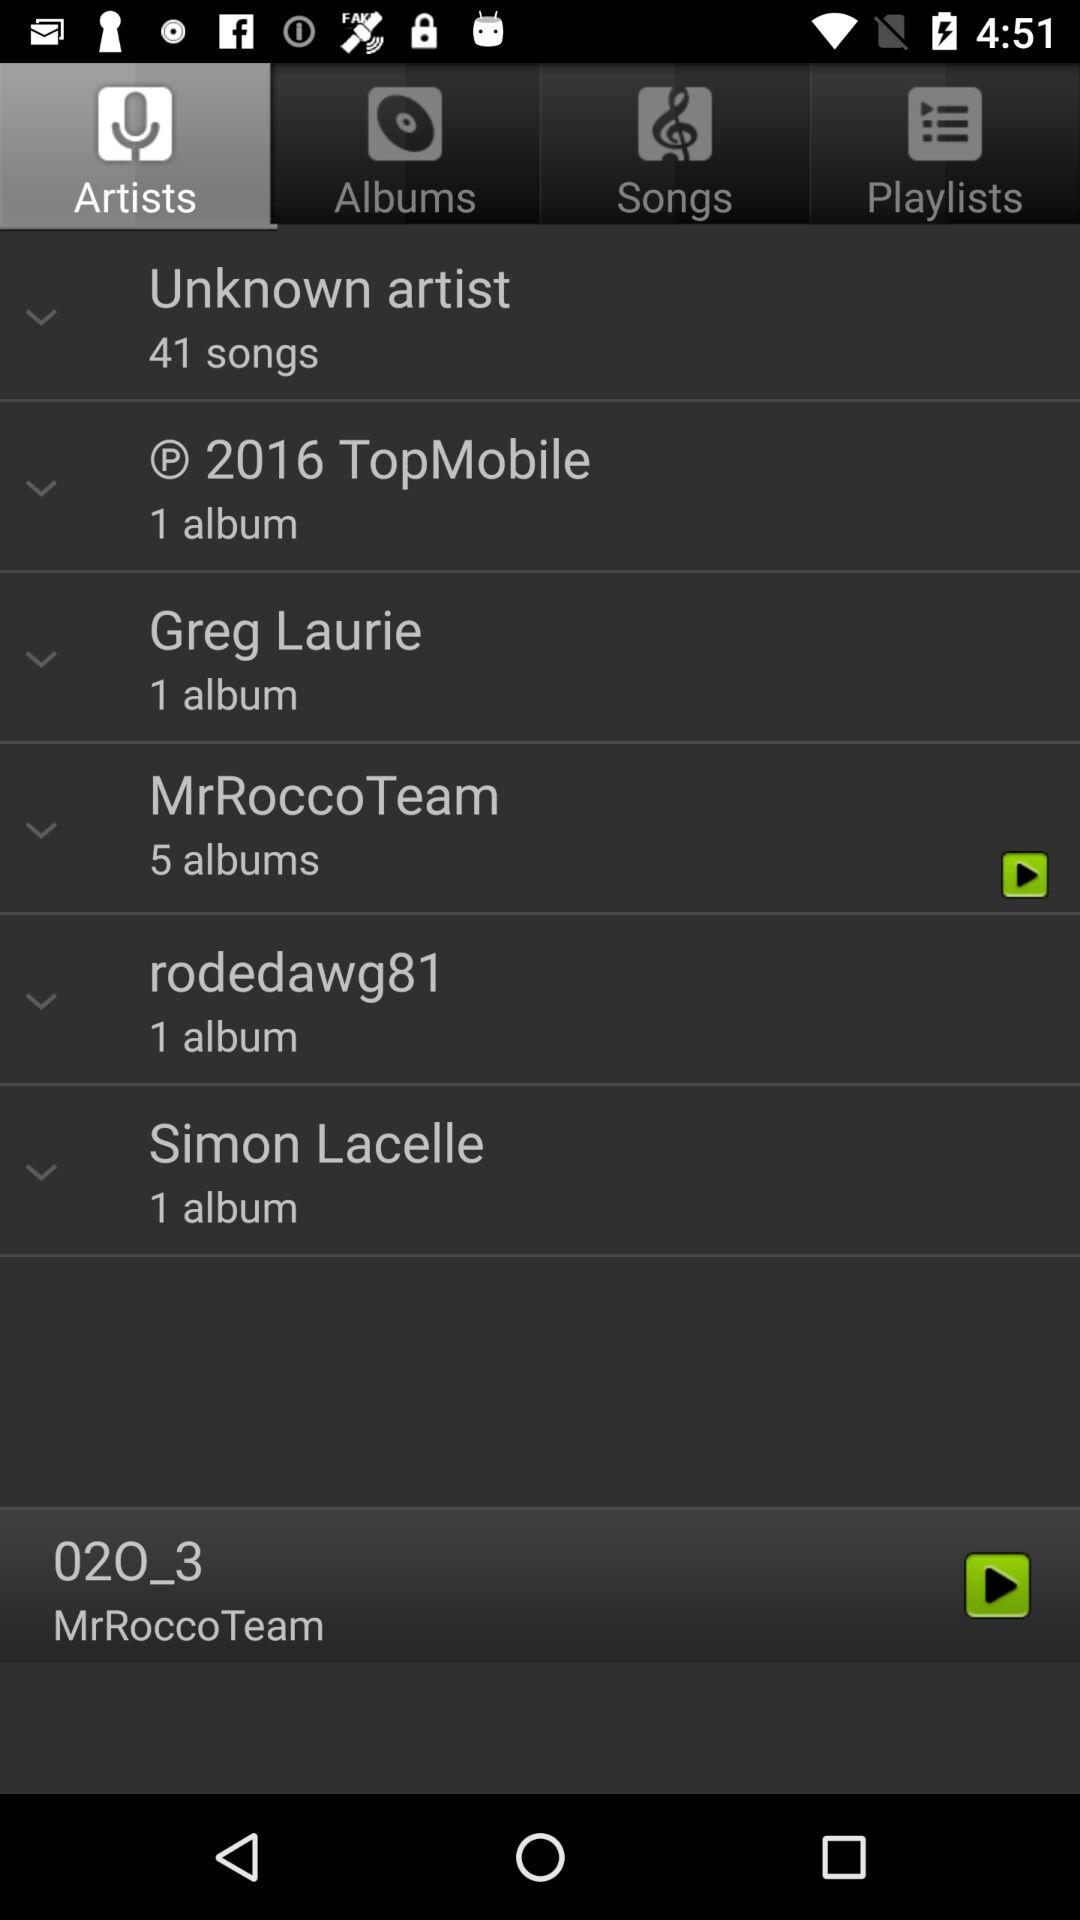Which song was last played? The song that was last played is "02O_3". 